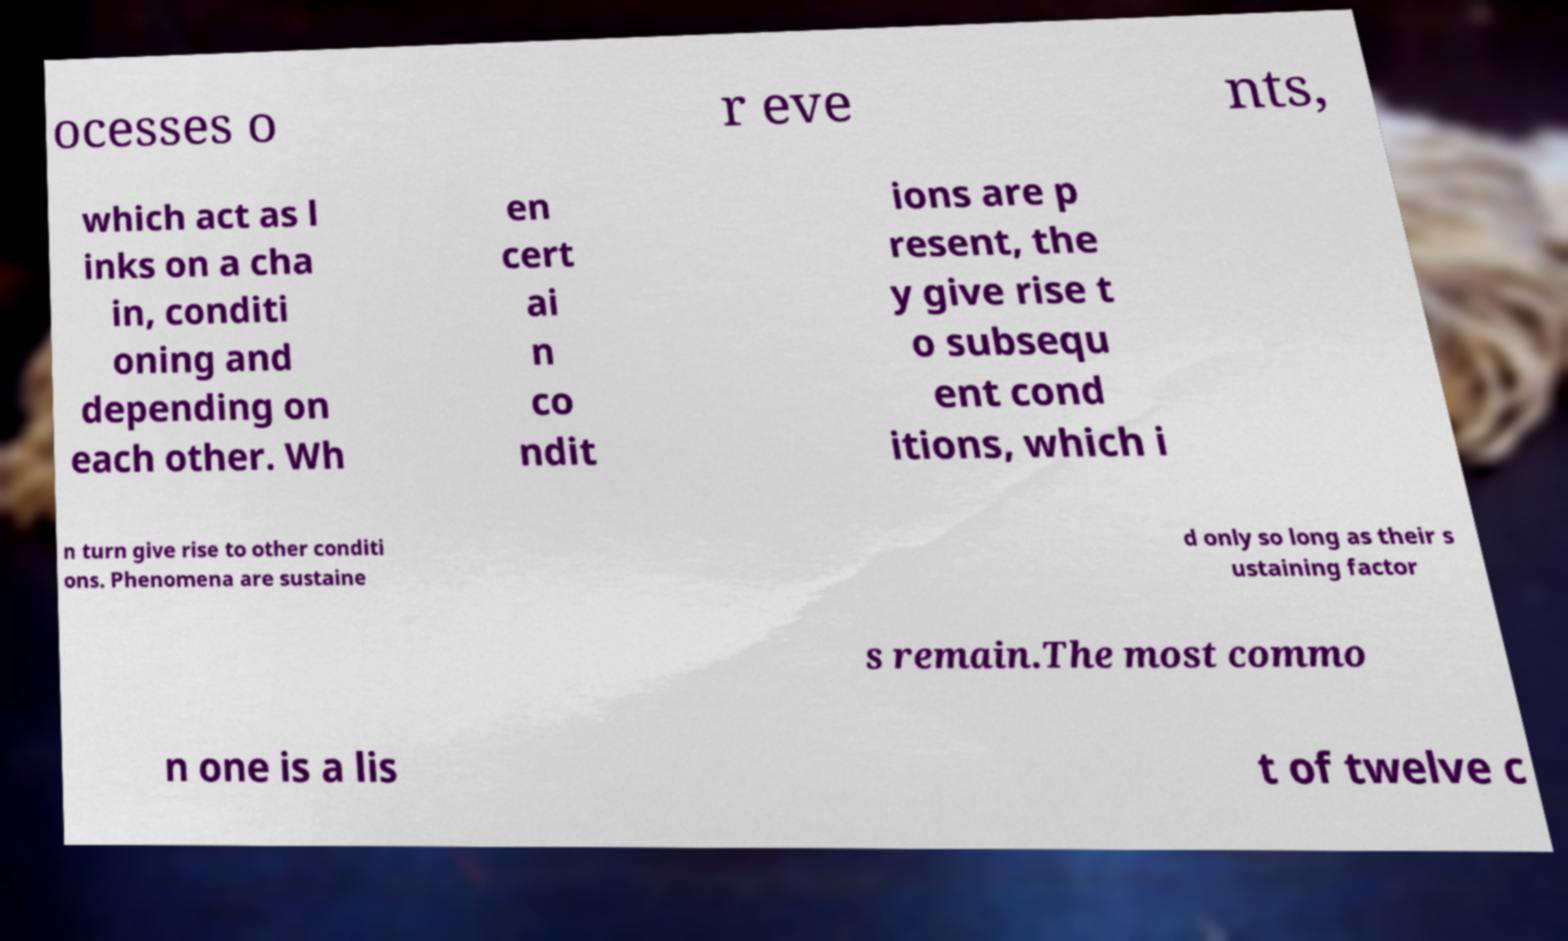Could you assist in decoding the text presented in this image and type it out clearly? ocesses o r eve nts, which act as l inks on a cha in, conditi oning and depending on each other. Wh en cert ai n co ndit ions are p resent, the y give rise t o subsequ ent cond itions, which i n turn give rise to other conditi ons. Phenomena are sustaine d only so long as their s ustaining factor s remain.The most commo n one is a lis t of twelve c 